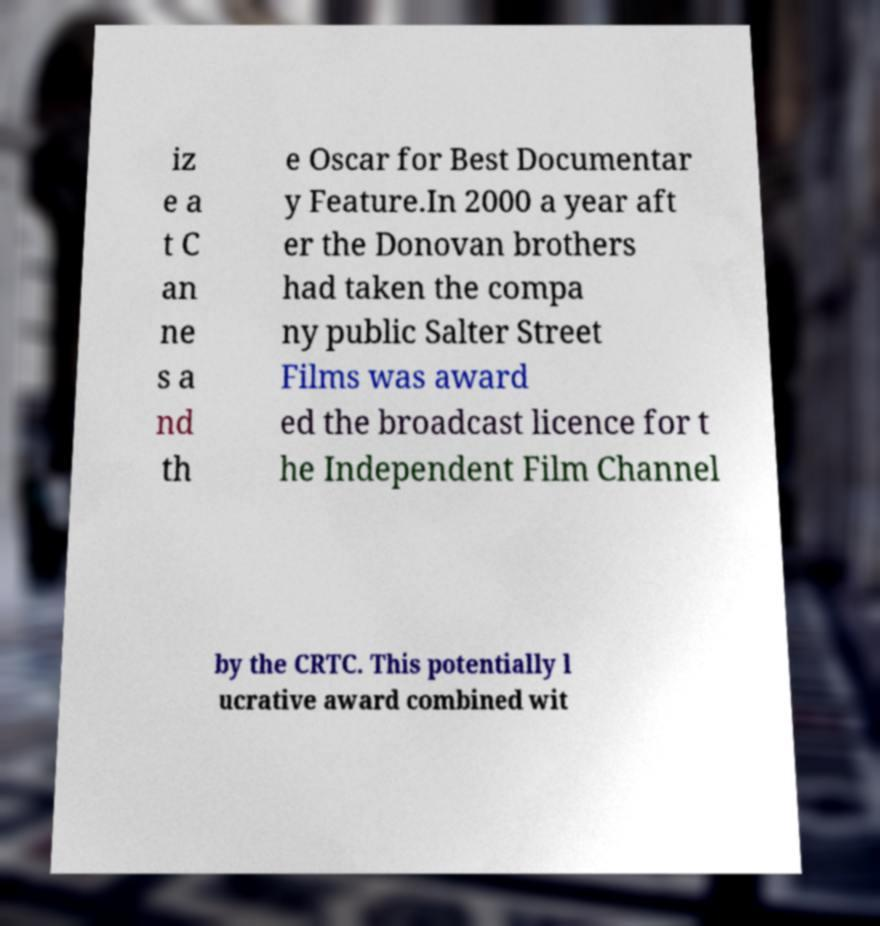Can you read and provide the text displayed in the image?This photo seems to have some interesting text. Can you extract and type it out for me? iz e a t C an ne s a nd th e Oscar for Best Documentar y Feature.In 2000 a year aft er the Donovan brothers had taken the compa ny public Salter Street Films was award ed the broadcast licence for t he Independent Film Channel by the CRTC. This potentially l ucrative award combined wit 